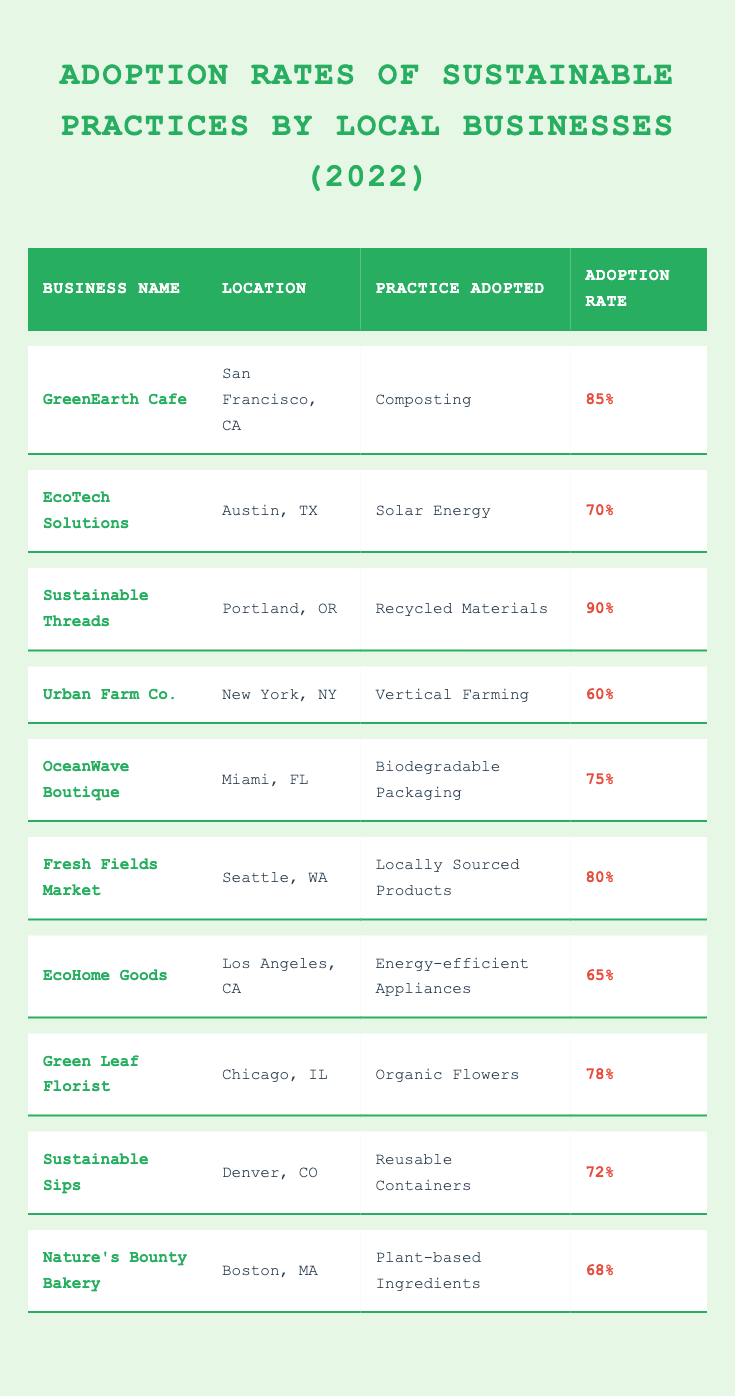What is the adoption rate of Sustainable Threads in Portland, OR? The table shows that Sustainable Threads, located in Portland, OR, adopted the practice of using Recycled Materials, with an adoption rate of 90%.
Answer: 90% Which business adopted the practice of composting? The table lists GreenEarth Cafe as the business that adopted composting, located in San Francisco, CA, with an adoption rate of 85%.
Answer: GreenEarth Cafe What is the average adoption rate of the practices listed in the table? To find the average, we sum the adoption rates: (85 + 70 + 90 + 60 + 75 + 80 + 65 + 78 + 72 + 68) = 810. There are 10 businesses, so the average is 810/10 = 81%.
Answer: 81% Did any business adopt a farming practice? The table indicates that Urban Farm Co., located in New York, NY, adopted the practice of Vertical Farming. Therefore, yes, there is a business that adopted a farming practice.
Answer: Yes After reviewing the table, is it true that EcoHome Goods has a higher adoption rate than Urban Farm Co.? EcoHome Goods has an adoption rate of 65%, while Urban Farm Co. has an adoption rate of 60%. Since 65% is greater than 60%, the statement is true.
Answer: Yes How many businesses adopted practices with rates above 70%? Upon reviewing the table, the businesses with adoption rates above 70% are GreenEarth Cafe, Sustainable Threads, Fresh Fields Market, OceanWave Boutique, and Green Leaf Florist, totaling 5 businesses.
Answer: 5 What percentage of businesses adopted practices concerning environmental materials, such as recycled or biodegradable? The businesses that adopted these practices are Sustainable Threads (Recycled Materials), OceanWave Boutique (Biodegradable Packaging), and fresh Fields Market (Locally Sourced Products). That makes three businesses out of ten, resulting in a percentage of (3/10) * 100 = 30%.
Answer: 30% 